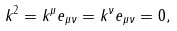Convert formula to latex. <formula><loc_0><loc_0><loc_500><loc_500>k ^ { 2 } = k ^ { \mu } e _ { \mu \nu } = k ^ { \nu } e _ { \mu \nu } = 0 ,</formula> 